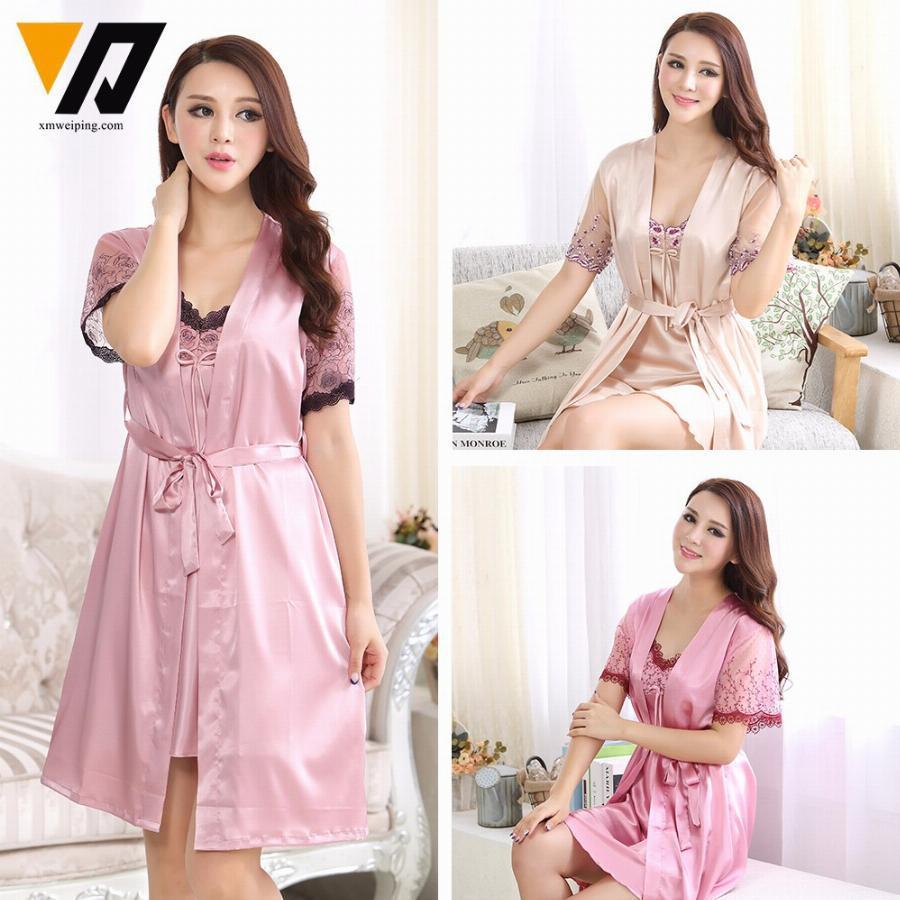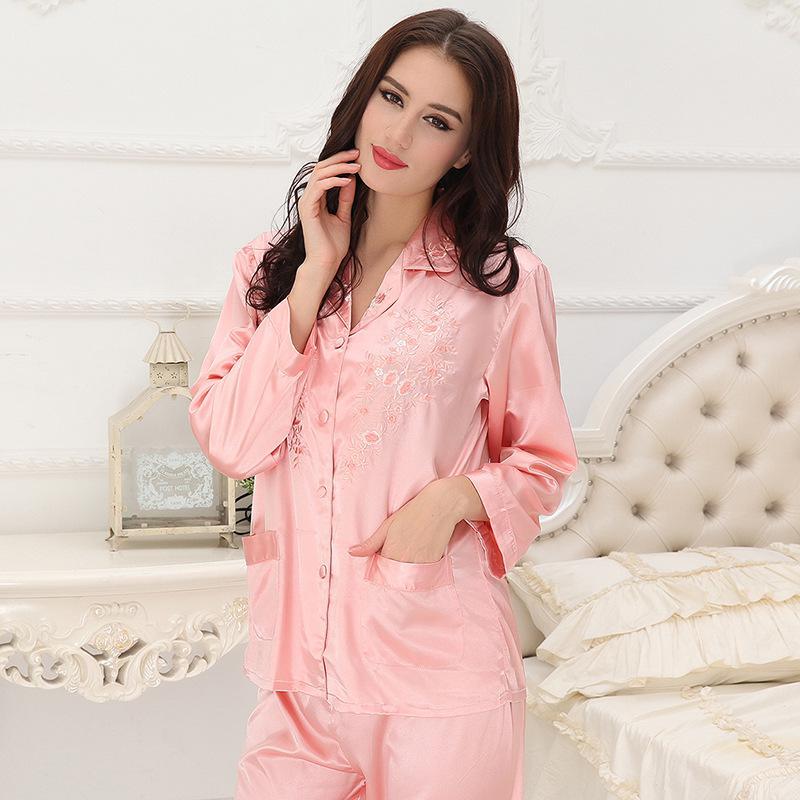The first image is the image on the left, the second image is the image on the right. For the images shown, is this caption "there is a woman in long sleeved pink pajamas in front of a window with window blinds" true? Answer yes or no. No. The first image is the image on the left, the second image is the image on the right. Analyze the images presented: Is the assertion "The combined images include three models in short gowns in pinkish pastel shades, one wearing a matching robe over the gown." valid? Answer yes or no. Yes. 